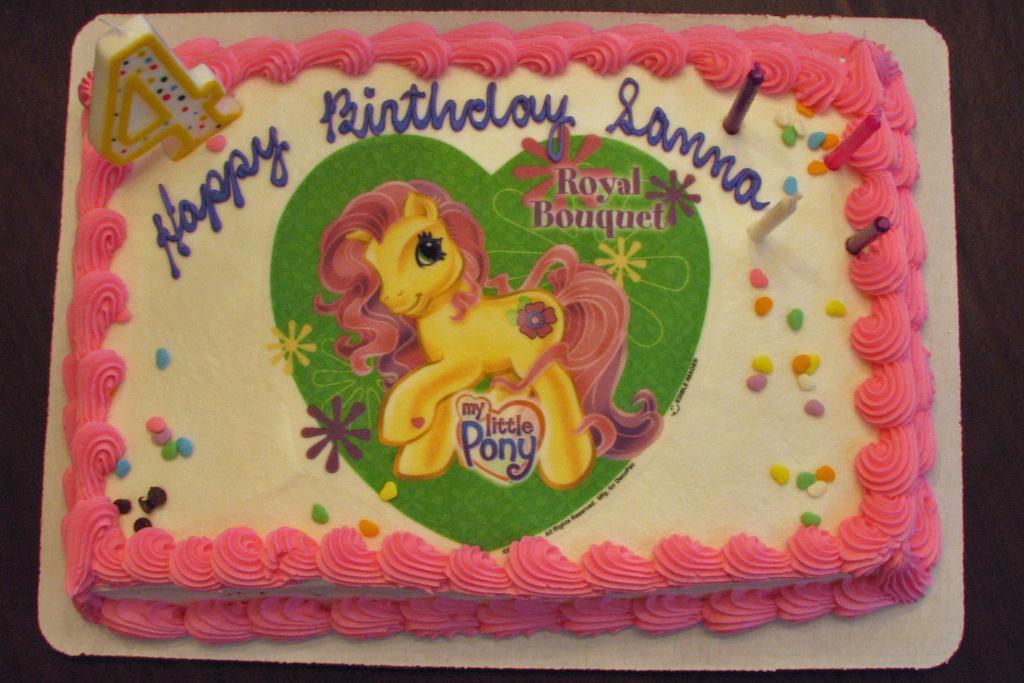In one or two sentences, can you explain what this image depicts? In this image we can see a cake with an image and the text and there are few candles on the cake. 